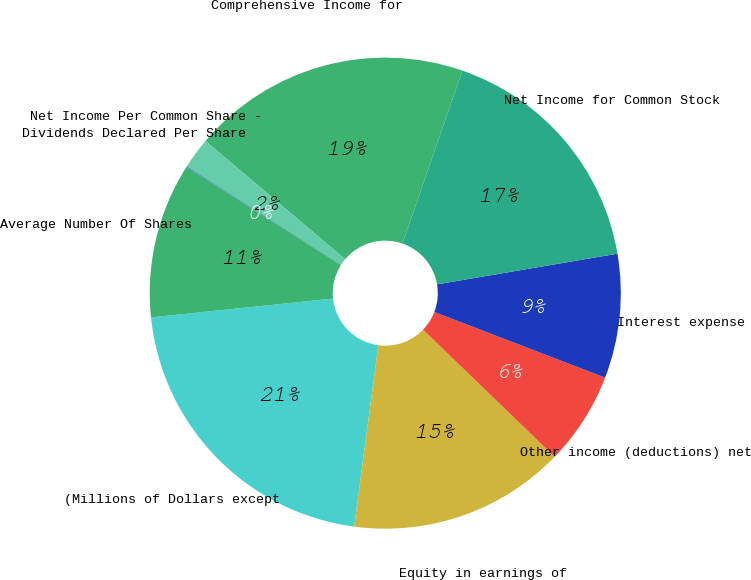Convert chart to OTSL. <chart><loc_0><loc_0><loc_500><loc_500><pie_chart><fcel>(Millions of Dollars except<fcel>Equity in earnings of<fcel>Other income (deductions) net<fcel>Interest expense<fcel>Net Income for Common Stock<fcel>Comprehensive Income for<fcel>Net Income Per Common Share -<fcel>Dividends Declared Per Share<fcel>Average Number Of Shares<nl><fcel>21.25%<fcel>14.88%<fcel>6.39%<fcel>8.52%<fcel>17.01%<fcel>19.13%<fcel>2.15%<fcel>0.03%<fcel>10.64%<nl></chart> 